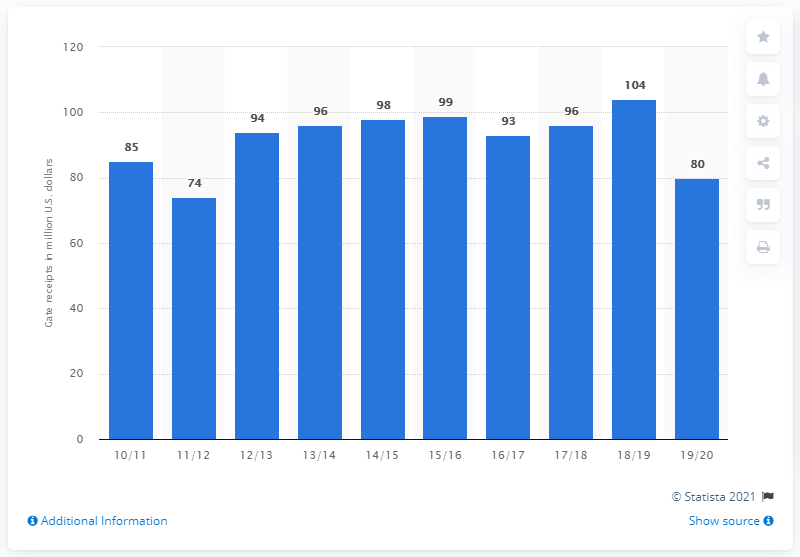Specify some key components in this picture. The gate receipts of the Los Angeles Lakers in the 2019/20 season were approximately 80. 